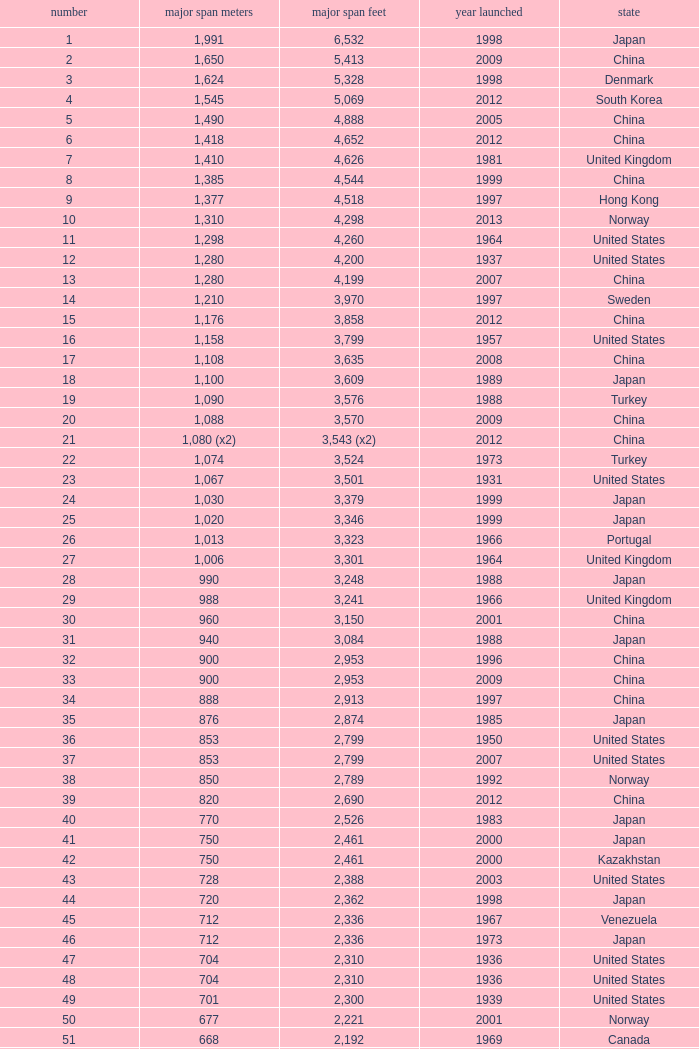What is the main span feet from opening year of 1936 in the United States with a rank greater than 47 and 421 main span metres? 1381.0. 